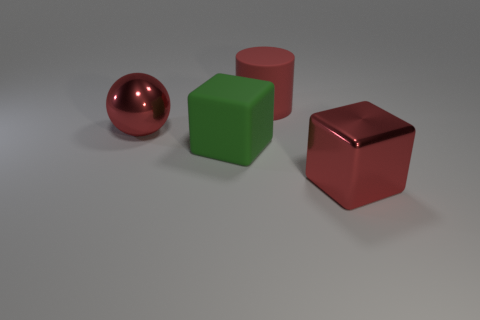Add 4 big purple cylinders. How many objects exist? 8 Subtract all spheres. How many objects are left? 3 Subtract all small green objects. Subtract all rubber blocks. How many objects are left? 3 Add 1 big red things. How many big red things are left? 4 Add 4 red metallic balls. How many red metallic balls exist? 5 Subtract 0 cyan spheres. How many objects are left? 4 